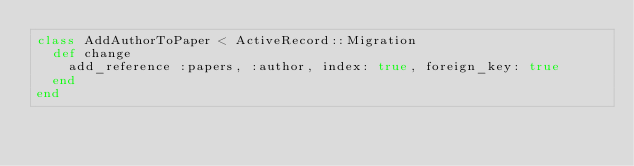Convert code to text. <code><loc_0><loc_0><loc_500><loc_500><_Ruby_>class AddAuthorToPaper < ActiveRecord::Migration
  def change
    add_reference :papers, :author, index: true, foreign_key: true
  end
end
</code> 